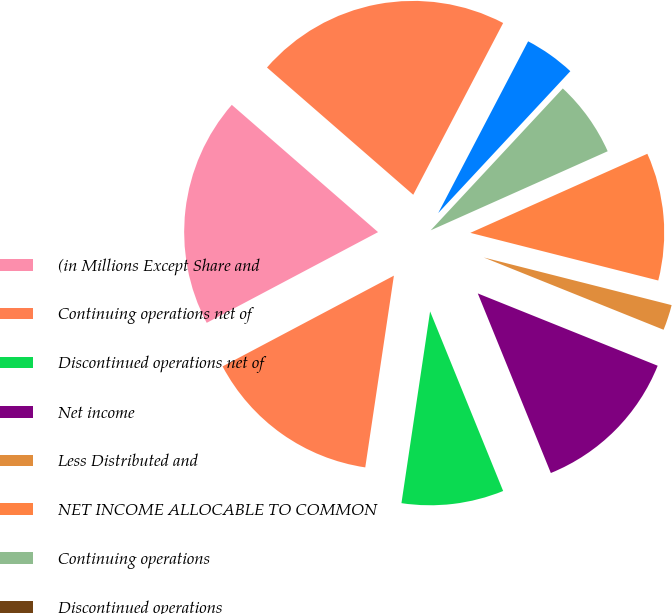Convert chart to OTSL. <chart><loc_0><loc_0><loc_500><loc_500><pie_chart><fcel>(in Millions Except Share and<fcel>Continuing operations net of<fcel>Discontinued operations net of<fcel>Net income<fcel>Less Distributed and<fcel>NET INCOME ALLOCABLE TO COMMON<fcel>Continuing operations<fcel>Discontinued operations<fcel>NET INCOME<fcel>Weighted average number of<nl><fcel>19.15%<fcel>14.89%<fcel>8.51%<fcel>12.77%<fcel>2.13%<fcel>10.64%<fcel>6.38%<fcel>0.0%<fcel>4.26%<fcel>21.28%<nl></chart> 